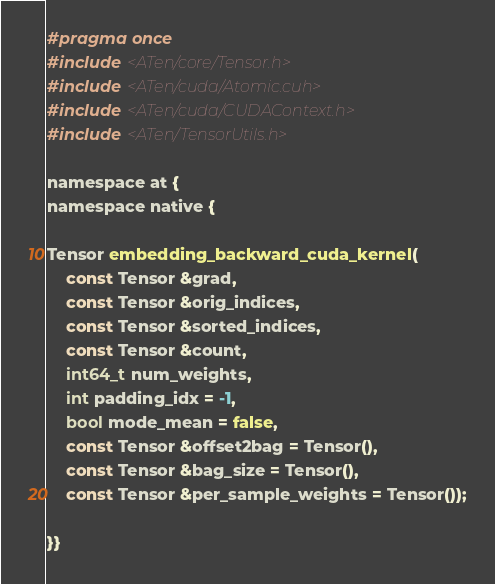<code> <loc_0><loc_0><loc_500><loc_500><_Cuda_>#pragma once
#include <ATen/core/Tensor.h>
#include <ATen/cuda/Atomic.cuh>
#include <ATen/cuda/CUDAContext.h>
#include <ATen/TensorUtils.h>

namespace at {
namespace native {

Tensor embedding_backward_cuda_kernel(
    const Tensor &grad,
    const Tensor &orig_indices,
    const Tensor &sorted_indices,
    const Tensor &count,
    int64_t num_weights,
    int padding_idx = -1,
    bool mode_mean = false,
    const Tensor &offset2bag = Tensor(),
    const Tensor &bag_size = Tensor(),
    const Tensor &per_sample_weights = Tensor());

}}
</code> 